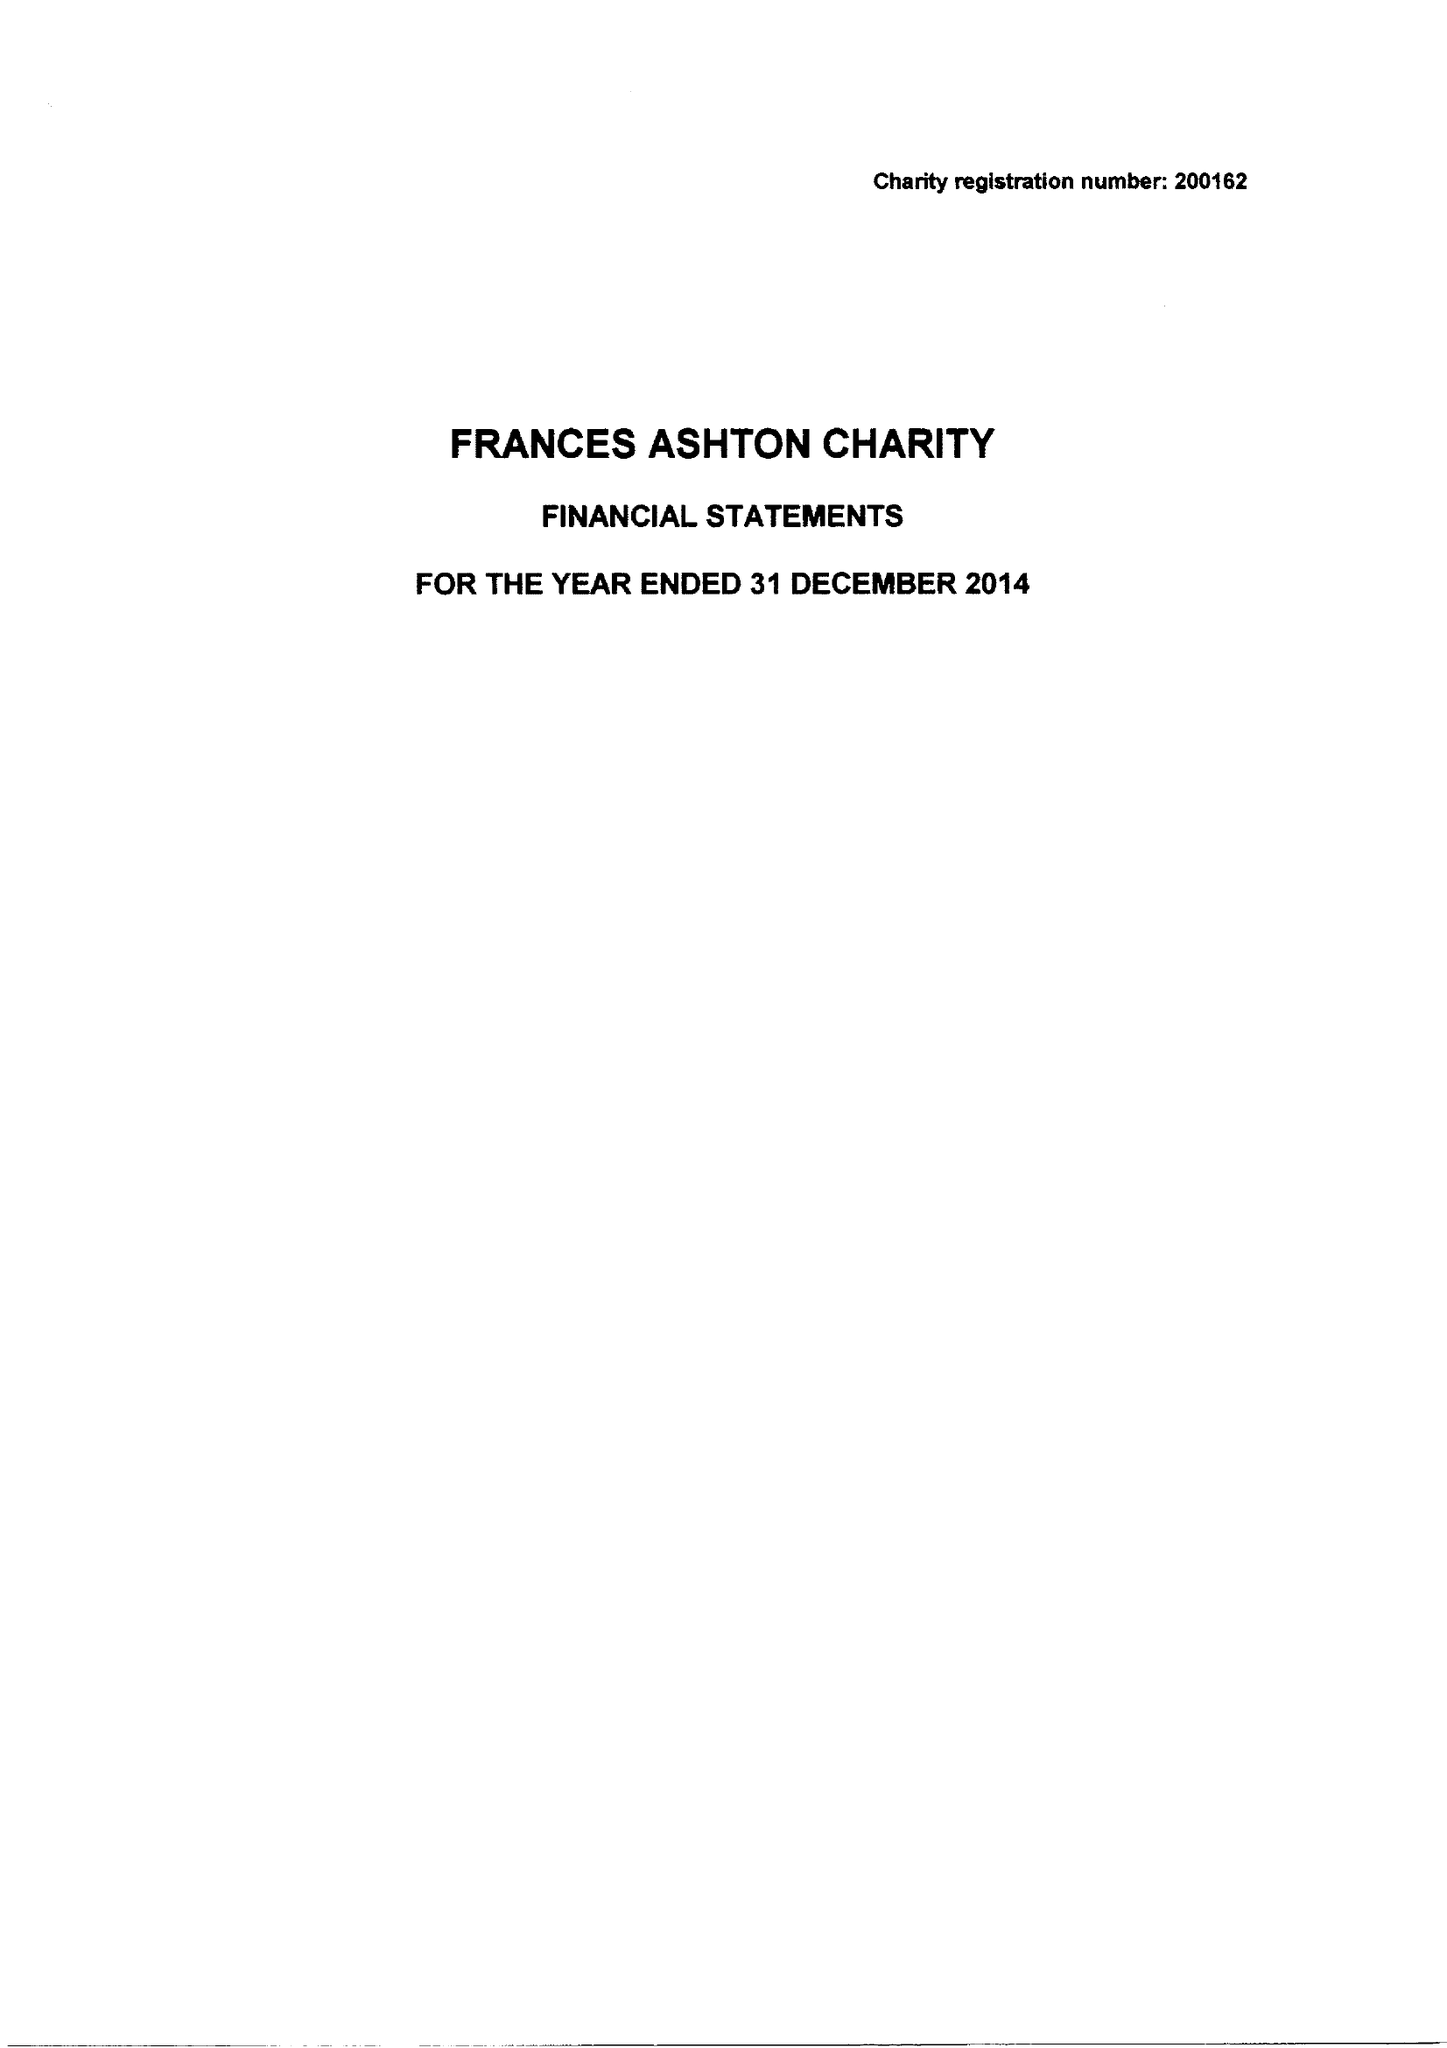What is the value for the address__postcode?
Answer the question using a single word or phrase. GU34 3JD 